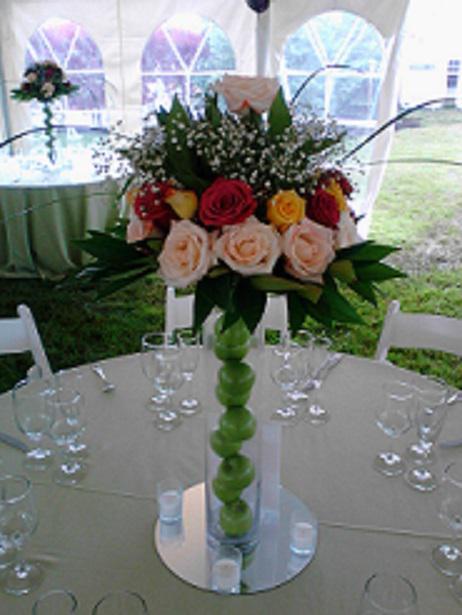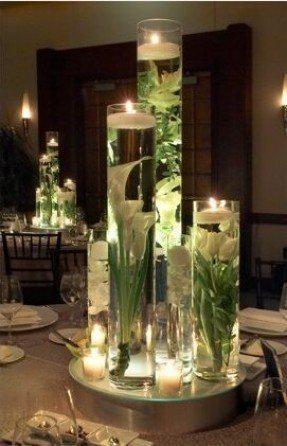The first image is the image on the left, the second image is the image on the right. Given the left and right images, does the statement "There are pink flowers in the vase in the image on the left." hold true? Answer yes or no. Yes. 